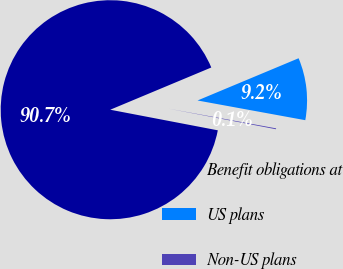Convert chart to OTSL. <chart><loc_0><loc_0><loc_500><loc_500><pie_chart><fcel>Benefit obligations at<fcel>US plans<fcel>Non-US plans<nl><fcel>90.69%<fcel>9.18%<fcel>0.13%<nl></chart> 